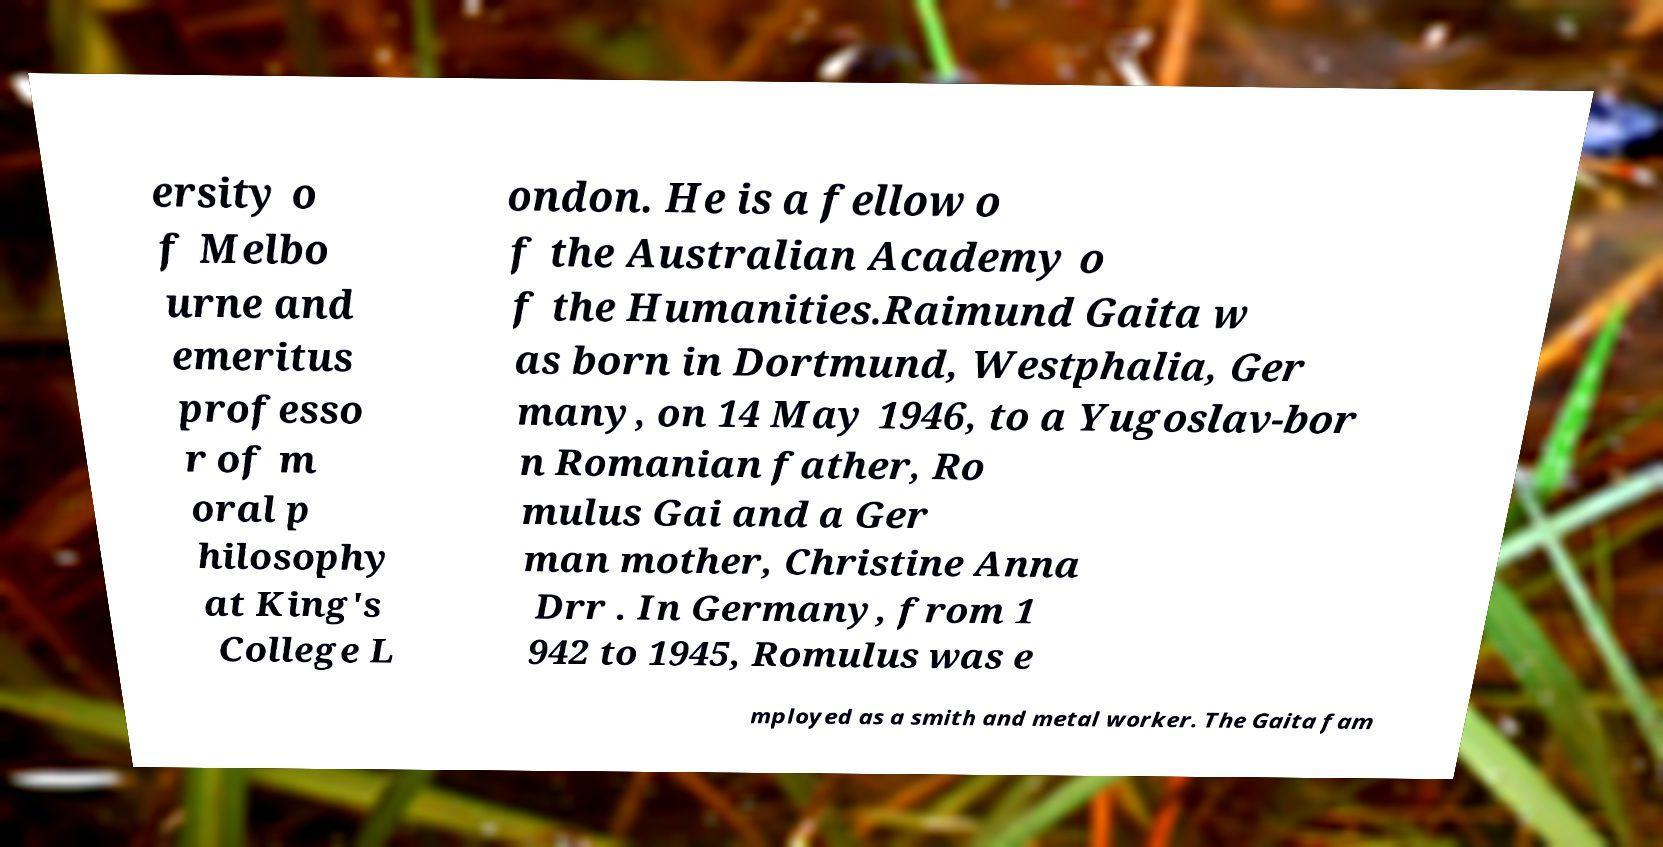There's text embedded in this image that I need extracted. Can you transcribe it verbatim? ersity o f Melbo urne and emeritus professo r of m oral p hilosophy at King's College L ondon. He is a fellow o f the Australian Academy o f the Humanities.Raimund Gaita w as born in Dortmund, Westphalia, Ger many, on 14 May 1946, to a Yugoslav-bor n Romanian father, Ro mulus Gai and a Ger man mother, Christine Anna Drr . In Germany, from 1 942 to 1945, Romulus was e mployed as a smith and metal worker. The Gaita fam 